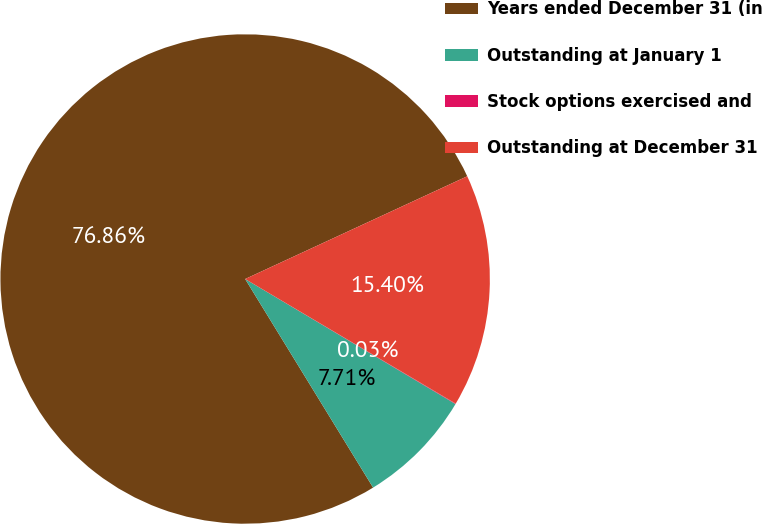Convert chart to OTSL. <chart><loc_0><loc_0><loc_500><loc_500><pie_chart><fcel>Years ended December 31 (in<fcel>Outstanding at January 1<fcel>Stock options exercised and<fcel>Outstanding at December 31<nl><fcel>76.86%<fcel>7.71%<fcel>0.03%<fcel>15.4%<nl></chart> 